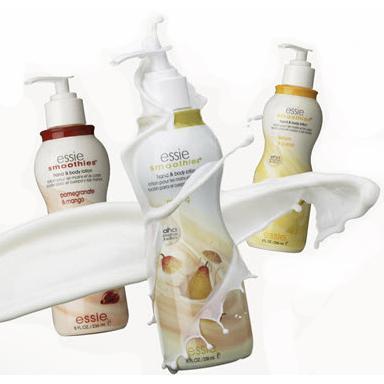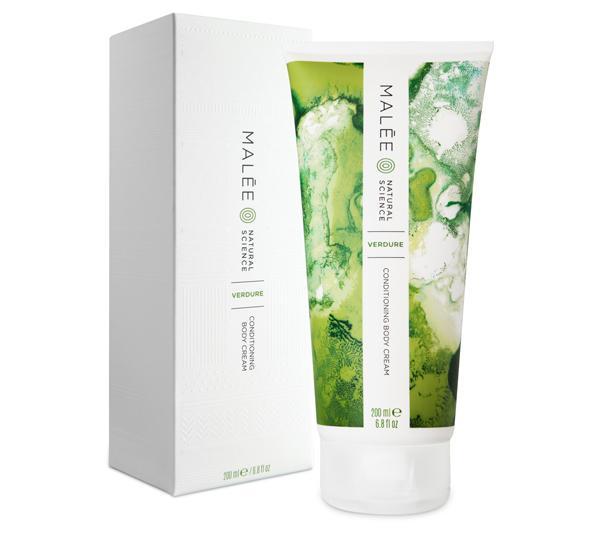The first image is the image on the left, the second image is the image on the right. For the images shown, is this caption "All skincare items shown have pump dispensers, and at least one image contains only one skincare item." true? Answer yes or no. No. The first image is the image on the left, the second image is the image on the right. For the images displayed, is the sentence "The left and right image contains the same number of soaps and lotions." factually correct? Answer yes or no. No. 